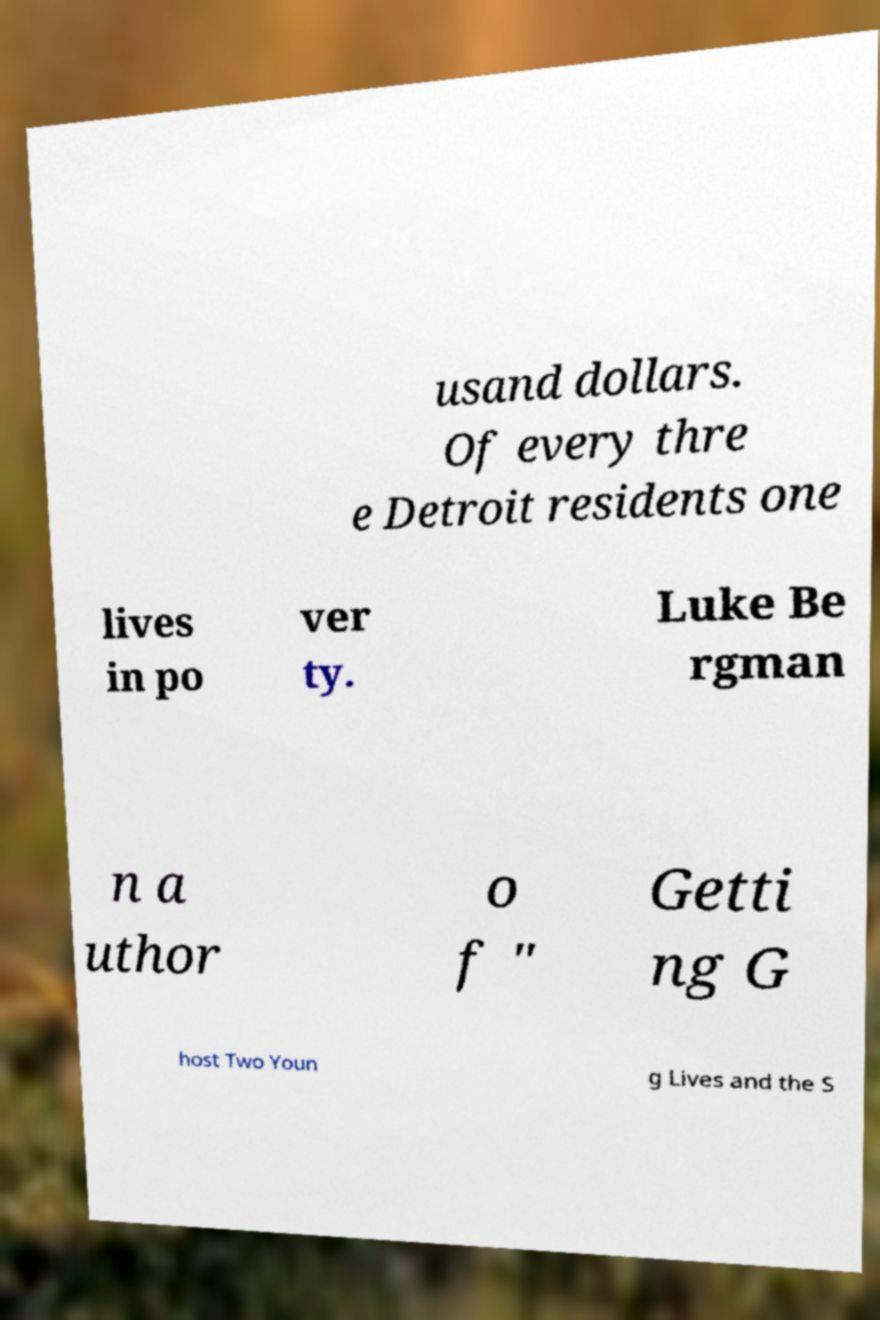For documentation purposes, I need the text within this image transcribed. Could you provide that? usand dollars. Of every thre e Detroit residents one lives in po ver ty. Luke Be rgman n a uthor o f " Getti ng G host Two Youn g Lives and the S 